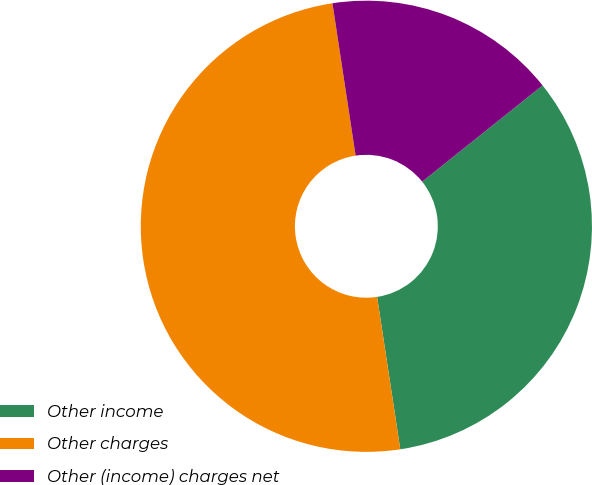Convert chart. <chart><loc_0><loc_0><loc_500><loc_500><pie_chart><fcel>Other income<fcel>Other charges<fcel>Other (income) charges net<nl><fcel>33.33%<fcel>50.0%<fcel>16.67%<nl></chart> 